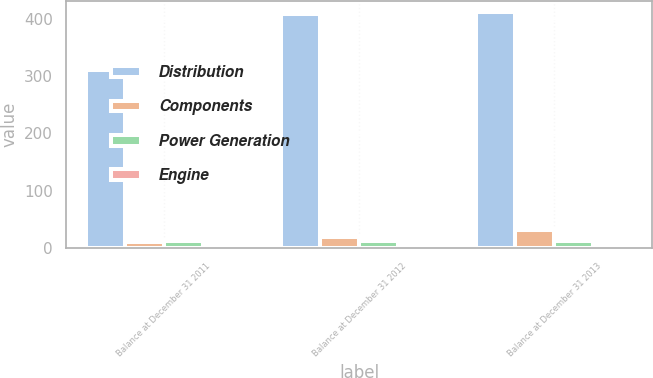Convert chart to OTSL. <chart><loc_0><loc_0><loc_500><loc_500><stacked_bar_chart><ecel><fcel>Balance at December 31 2011<fcel>Balance at December 31 2012<fcel>Balance at December 31 2013<nl><fcel>Distribution<fcel>311<fcel>408<fcel>411<nl><fcel>Components<fcel>10<fcel>19<fcel>31<nl><fcel>Power Generation<fcel>12<fcel>12<fcel>13<nl><fcel>Engine<fcel>6<fcel>6<fcel>6<nl></chart> 